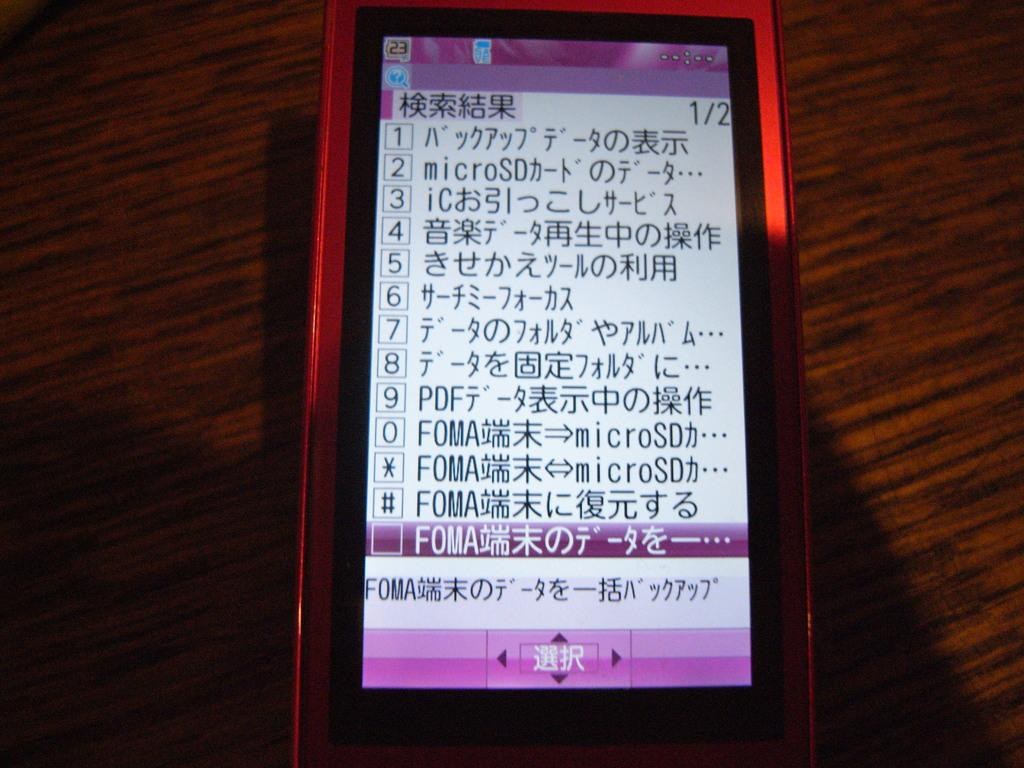Provide a one-sentence caption for the provided image. The phone shows a list in another language besides English.. 